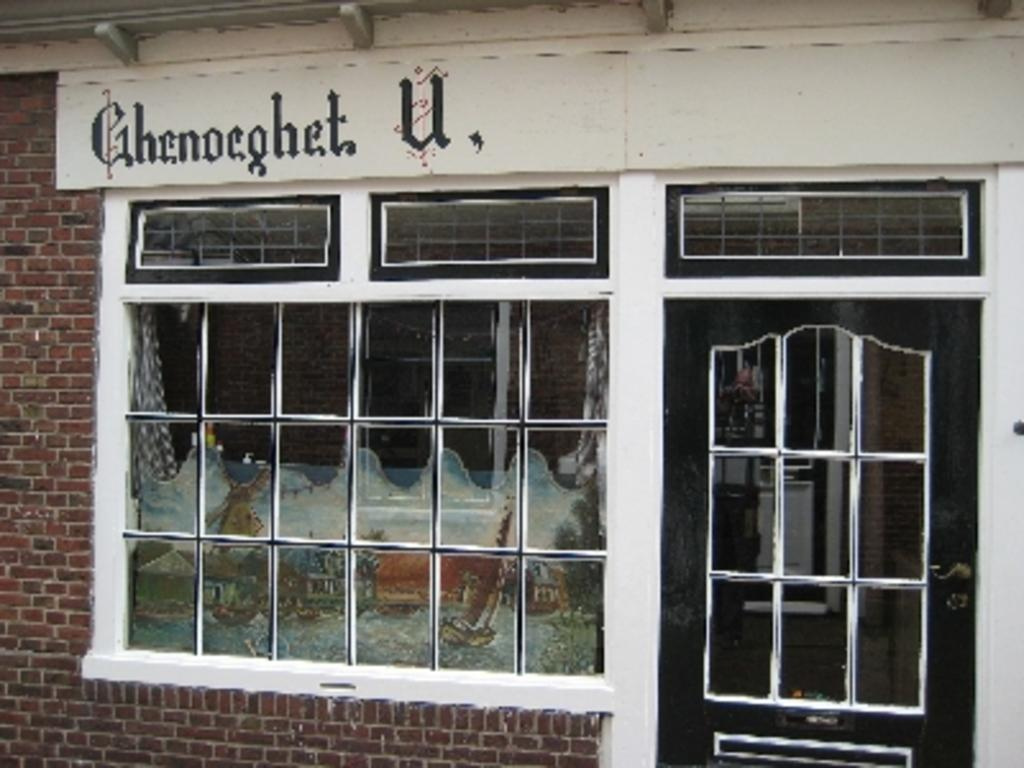<image>
Present a compact description of the photo's key features. A storefront with the name Ghenoeghet U on it. 